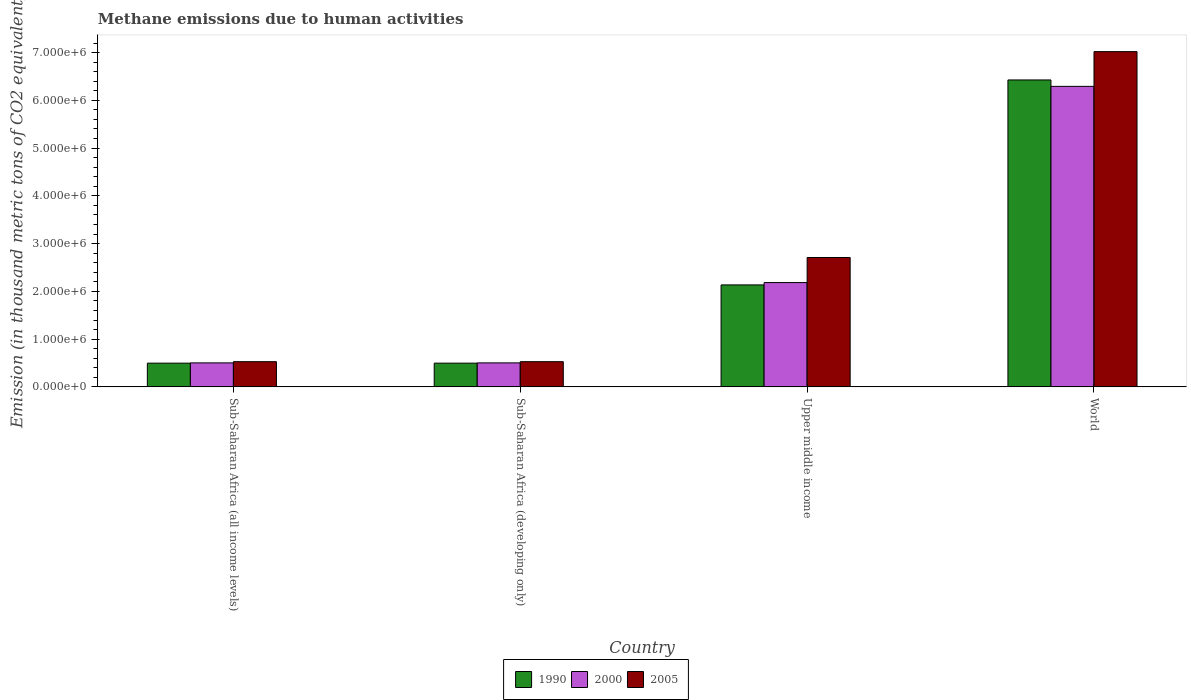How many different coloured bars are there?
Ensure brevity in your answer.  3. How many groups of bars are there?
Your answer should be compact. 4. How many bars are there on the 3rd tick from the left?
Offer a very short reply. 3. What is the label of the 3rd group of bars from the left?
Your answer should be very brief. Upper middle income. In how many cases, is the number of bars for a given country not equal to the number of legend labels?
Ensure brevity in your answer.  0. What is the amount of methane emitted in 2000 in World?
Ensure brevity in your answer.  6.29e+06. Across all countries, what is the maximum amount of methane emitted in 2005?
Your answer should be compact. 7.02e+06. Across all countries, what is the minimum amount of methane emitted in 2000?
Your response must be concise. 5.02e+05. In which country was the amount of methane emitted in 2005 minimum?
Keep it short and to the point. Sub-Saharan Africa (all income levels). What is the total amount of methane emitted in 2000 in the graph?
Your answer should be very brief. 9.48e+06. What is the difference between the amount of methane emitted in 2005 in Sub-Saharan Africa (developing only) and that in Upper middle income?
Make the answer very short. -2.18e+06. What is the difference between the amount of methane emitted in 2000 in Sub-Saharan Africa (all income levels) and the amount of methane emitted in 1990 in Upper middle income?
Offer a terse response. -1.63e+06. What is the average amount of methane emitted in 1990 per country?
Make the answer very short. 2.39e+06. What is the difference between the amount of methane emitted of/in 1990 and amount of methane emitted of/in 2000 in Sub-Saharan Africa (developing only)?
Your answer should be compact. -5608.2. What is the ratio of the amount of methane emitted in 2005 in Sub-Saharan Africa (developing only) to that in World?
Make the answer very short. 0.08. What is the difference between the highest and the second highest amount of methane emitted in 2005?
Your answer should be very brief. -4.31e+06. What is the difference between the highest and the lowest amount of methane emitted in 2005?
Ensure brevity in your answer.  6.49e+06. What does the 2nd bar from the right in Sub-Saharan Africa (developing only) represents?
Offer a terse response. 2000. Is it the case that in every country, the sum of the amount of methane emitted in 2000 and amount of methane emitted in 1990 is greater than the amount of methane emitted in 2005?
Your answer should be very brief. Yes. How many bars are there?
Your response must be concise. 12. How many countries are there in the graph?
Ensure brevity in your answer.  4. What is the difference between two consecutive major ticks on the Y-axis?
Give a very brief answer. 1.00e+06. Does the graph contain any zero values?
Ensure brevity in your answer.  No. Does the graph contain grids?
Give a very brief answer. No. Where does the legend appear in the graph?
Keep it short and to the point. Bottom center. How many legend labels are there?
Make the answer very short. 3. What is the title of the graph?
Give a very brief answer. Methane emissions due to human activities. What is the label or title of the X-axis?
Your answer should be very brief. Country. What is the label or title of the Y-axis?
Ensure brevity in your answer.  Emission (in thousand metric tons of CO2 equivalent). What is the Emission (in thousand metric tons of CO2 equivalent) in 1990 in Sub-Saharan Africa (all income levels)?
Your response must be concise. 4.97e+05. What is the Emission (in thousand metric tons of CO2 equivalent) of 2000 in Sub-Saharan Africa (all income levels)?
Provide a short and direct response. 5.02e+05. What is the Emission (in thousand metric tons of CO2 equivalent) in 2005 in Sub-Saharan Africa (all income levels)?
Your response must be concise. 5.27e+05. What is the Emission (in thousand metric tons of CO2 equivalent) in 1990 in Sub-Saharan Africa (developing only)?
Ensure brevity in your answer.  4.97e+05. What is the Emission (in thousand metric tons of CO2 equivalent) of 2000 in Sub-Saharan Africa (developing only)?
Ensure brevity in your answer.  5.02e+05. What is the Emission (in thousand metric tons of CO2 equivalent) in 2005 in Sub-Saharan Africa (developing only)?
Make the answer very short. 5.27e+05. What is the Emission (in thousand metric tons of CO2 equivalent) in 1990 in Upper middle income?
Give a very brief answer. 2.13e+06. What is the Emission (in thousand metric tons of CO2 equivalent) in 2000 in Upper middle income?
Keep it short and to the point. 2.18e+06. What is the Emission (in thousand metric tons of CO2 equivalent) of 2005 in Upper middle income?
Offer a terse response. 2.71e+06. What is the Emission (in thousand metric tons of CO2 equivalent) in 1990 in World?
Your answer should be very brief. 6.43e+06. What is the Emission (in thousand metric tons of CO2 equivalent) of 2000 in World?
Offer a very short reply. 6.29e+06. What is the Emission (in thousand metric tons of CO2 equivalent) of 2005 in World?
Provide a short and direct response. 7.02e+06. Across all countries, what is the maximum Emission (in thousand metric tons of CO2 equivalent) of 1990?
Provide a short and direct response. 6.43e+06. Across all countries, what is the maximum Emission (in thousand metric tons of CO2 equivalent) of 2000?
Offer a very short reply. 6.29e+06. Across all countries, what is the maximum Emission (in thousand metric tons of CO2 equivalent) of 2005?
Your answer should be compact. 7.02e+06. Across all countries, what is the minimum Emission (in thousand metric tons of CO2 equivalent) of 1990?
Your answer should be very brief. 4.97e+05. Across all countries, what is the minimum Emission (in thousand metric tons of CO2 equivalent) of 2000?
Provide a succinct answer. 5.02e+05. Across all countries, what is the minimum Emission (in thousand metric tons of CO2 equivalent) in 2005?
Offer a terse response. 5.27e+05. What is the total Emission (in thousand metric tons of CO2 equivalent) in 1990 in the graph?
Your response must be concise. 9.55e+06. What is the total Emission (in thousand metric tons of CO2 equivalent) of 2000 in the graph?
Offer a terse response. 9.48e+06. What is the total Emission (in thousand metric tons of CO2 equivalent) of 2005 in the graph?
Provide a succinct answer. 1.08e+07. What is the difference between the Emission (in thousand metric tons of CO2 equivalent) of 2005 in Sub-Saharan Africa (all income levels) and that in Sub-Saharan Africa (developing only)?
Ensure brevity in your answer.  0. What is the difference between the Emission (in thousand metric tons of CO2 equivalent) of 1990 in Sub-Saharan Africa (all income levels) and that in Upper middle income?
Provide a short and direct response. -1.64e+06. What is the difference between the Emission (in thousand metric tons of CO2 equivalent) in 2000 in Sub-Saharan Africa (all income levels) and that in Upper middle income?
Provide a short and direct response. -1.68e+06. What is the difference between the Emission (in thousand metric tons of CO2 equivalent) in 2005 in Sub-Saharan Africa (all income levels) and that in Upper middle income?
Provide a short and direct response. -2.18e+06. What is the difference between the Emission (in thousand metric tons of CO2 equivalent) of 1990 in Sub-Saharan Africa (all income levels) and that in World?
Offer a terse response. -5.93e+06. What is the difference between the Emission (in thousand metric tons of CO2 equivalent) of 2000 in Sub-Saharan Africa (all income levels) and that in World?
Give a very brief answer. -5.79e+06. What is the difference between the Emission (in thousand metric tons of CO2 equivalent) in 2005 in Sub-Saharan Africa (all income levels) and that in World?
Your answer should be compact. -6.49e+06. What is the difference between the Emission (in thousand metric tons of CO2 equivalent) in 1990 in Sub-Saharan Africa (developing only) and that in Upper middle income?
Provide a succinct answer. -1.64e+06. What is the difference between the Emission (in thousand metric tons of CO2 equivalent) of 2000 in Sub-Saharan Africa (developing only) and that in Upper middle income?
Offer a terse response. -1.68e+06. What is the difference between the Emission (in thousand metric tons of CO2 equivalent) of 2005 in Sub-Saharan Africa (developing only) and that in Upper middle income?
Make the answer very short. -2.18e+06. What is the difference between the Emission (in thousand metric tons of CO2 equivalent) in 1990 in Sub-Saharan Africa (developing only) and that in World?
Provide a succinct answer. -5.93e+06. What is the difference between the Emission (in thousand metric tons of CO2 equivalent) in 2000 in Sub-Saharan Africa (developing only) and that in World?
Offer a very short reply. -5.79e+06. What is the difference between the Emission (in thousand metric tons of CO2 equivalent) in 2005 in Sub-Saharan Africa (developing only) and that in World?
Your answer should be very brief. -6.49e+06. What is the difference between the Emission (in thousand metric tons of CO2 equivalent) in 1990 in Upper middle income and that in World?
Give a very brief answer. -4.29e+06. What is the difference between the Emission (in thousand metric tons of CO2 equivalent) in 2000 in Upper middle income and that in World?
Offer a very short reply. -4.11e+06. What is the difference between the Emission (in thousand metric tons of CO2 equivalent) of 2005 in Upper middle income and that in World?
Ensure brevity in your answer.  -4.31e+06. What is the difference between the Emission (in thousand metric tons of CO2 equivalent) of 1990 in Sub-Saharan Africa (all income levels) and the Emission (in thousand metric tons of CO2 equivalent) of 2000 in Sub-Saharan Africa (developing only)?
Offer a terse response. -5608.2. What is the difference between the Emission (in thousand metric tons of CO2 equivalent) in 1990 in Sub-Saharan Africa (all income levels) and the Emission (in thousand metric tons of CO2 equivalent) in 2005 in Sub-Saharan Africa (developing only)?
Offer a very short reply. -3.07e+04. What is the difference between the Emission (in thousand metric tons of CO2 equivalent) in 2000 in Sub-Saharan Africa (all income levels) and the Emission (in thousand metric tons of CO2 equivalent) in 2005 in Sub-Saharan Africa (developing only)?
Your answer should be very brief. -2.51e+04. What is the difference between the Emission (in thousand metric tons of CO2 equivalent) of 1990 in Sub-Saharan Africa (all income levels) and the Emission (in thousand metric tons of CO2 equivalent) of 2000 in Upper middle income?
Keep it short and to the point. -1.69e+06. What is the difference between the Emission (in thousand metric tons of CO2 equivalent) in 1990 in Sub-Saharan Africa (all income levels) and the Emission (in thousand metric tons of CO2 equivalent) in 2005 in Upper middle income?
Your answer should be very brief. -2.21e+06. What is the difference between the Emission (in thousand metric tons of CO2 equivalent) of 2000 in Sub-Saharan Africa (all income levels) and the Emission (in thousand metric tons of CO2 equivalent) of 2005 in Upper middle income?
Offer a terse response. -2.21e+06. What is the difference between the Emission (in thousand metric tons of CO2 equivalent) in 1990 in Sub-Saharan Africa (all income levels) and the Emission (in thousand metric tons of CO2 equivalent) in 2000 in World?
Your response must be concise. -5.80e+06. What is the difference between the Emission (in thousand metric tons of CO2 equivalent) in 1990 in Sub-Saharan Africa (all income levels) and the Emission (in thousand metric tons of CO2 equivalent) in 2005 in World?
Ensure brevity in your answer.  -6.52e+06. What is the difference between the Emission (in thousand metric tons of CO2 equivalent) in 2000 in Sub-Saharan Africa (all income levels) and the Emission (in thousand metric tons of CO2 equivalent) in 2005 in World?
Make the answer very short. -6.52e+06. What is the difference between the Emission (in thousand metric tons of CO2 equivalent) of 1990 in Sub-Saharan Africa (developing only) and the Emission (in thousand metric tons of CO2 equivalent) of 2000 in Upper middle income?
Provide a succinct answer. -1.69e+06. What is the difference between the Emission (in thousand metric tons of CO2 equivalent) of 1990 in Sub-Saharan Africa (developing only) and the Emission (in thousand metric tons of CO2 equivalent) of 2005 in Upper middle income?
Ensure brevity in your answer.  -2.21e+06. What is the difference between the Emission (in thousand metric tons of CO2 equivalent) of 2000 in Sub-Saharan Africa (developing only) and the Emission (in thousand metric tons of CO2 equivalent) of 2005 in Upper middle income?
Provide a succinct answer. -2.21e+06. What is the difference between the Emission (in thousand metric tons of CO2 equivalent) of 1990 in Sub-Saharan Africa (developing only) and the Emission (in thousand metric tons of CO2 equivalent) of 2000 in World?
Provide a succinct answer. -5.80e+06. What is the difference between the Emission (in thousand metric tons of CO2 equivalent) of 1990 in Sub-Saharan Africa (developing only) and the Emission (in thousand metric tons of CO2 equivalent) of 2005 in World?
Your answer should be very brief. -6.52e+06. What is the difference between the Emission (in thousand metric tons of CO2 equivalent) of 2000 in Sub-Saharan Africa (developing only) and the Emission (in thousand metric tons of CO2 equivalent) of 2005 in World?
Your answer should be compact. -6.52e+06. What is the difference between the Emission (in thousand metric tons of CO2 equivalent) of 1990 in Upper middle income and the Emission (in thousand metric tons of CO2 equivalent) of 2000 in World?
Provide a succinct answer. -4.16e+06. What is the difference between the Emission (in thousand metric tons of CO2 equivalent) of 1990 in Upper middle income and the Emission (in thousand metric tons of CO2 equivalent) of 2005 in World?
Offer a terse response. -4.88e+06. What is the difference between the Emission (in thousand metric tons of CO2 equivalent) of 2000 in Upper middle income and the Emission (in thousand metric tons of CO2 equivalent) of 2005 in World?
Give a very brief answer. -4.84e+06. What is the average Emission (in thousand metric tons of CO2 equivalent) of 1990 per country?
Offer a very short reply. 2.39e+06. What is the average Emission (in thousand metric tons of CO2 equivalent) in 2000 per country?
Offer a very short reply. 2.37e+06. What is the average Emission (in thousand metric tons of CO2 equivalent) in 2005 per country?
Keep it short and to the point. 2.70e+06. What is the difference between the Emission (in thousand metric tons of CO2 equivalent) in 1990 and Emission (in thousand metric tons of CO2 equivalent) in 2000 in Sub-Saharan Africa (all income levels)?
Your answer should be compact. -5608.2. What is the difference between the Emission (in thousand metric tons of CO2 equivalent) of 1990 and Emission (in thousand metric tons of CO2 equivalent) of 2005 in Sub-Saharan Africa (all income levels)?
Keep it short and to the point. -3.07e+04. What is the difference between the Emission (in thousand metric tons of CO2 equivalent) in 2000 and Emission (in thousand metric tons of CO2 equivalent) in 2005 in Sub-Saharan Africa (all income levels)?
Offer a very short reply. -2.51e+04. What is the difference between the Emission (in thousand metric tons of CO2 equivalent) in 1990 and Emission (in thousand metric tons of CO2 equivalent) in 2000 in Sub-Saharan Africa (developing only)?
Give a very brief answer. -5608.2. What is the difference between the Emission (in thousand metric tons of CO2 equivalent) in 1990 and Emission (in thousand metric tons of CO2 equivalent) in 2005 in Sub-Saharan Africa (developing only)?
Provide a short and direct response. -3.07e+04. What is the difference between the Emission (in thousand metric tons of CO2 equivalent) of 2000 and Emission (in thousand metric tons of CO2 equivalent) of 2005 in Sub-Saharan Africa (developing only)?
Provide a succinct answer. -2.51e+04. What is the difference between the Emission (in thousand metric tons of CO2 equivalent) of 1990 and Emission (in thousand metric tons of CO2 equivalent) of 2000 in Upper middle income?
Offer a terse response. -4.89e+04. What is the difference between the Emission (in thousand metric tons of CO2 equivalent) of 1990 and Emission (in thousand metric tons of CO2 equivalent) of 2005 in Upper middle income?
Keep it short and to the point. -5.74e+05. What is the difference between the Emission (in thousand metric tons of CO2 equivalent) of 2000 and Emission (in thousand metric tons of CO2 equivalent) of 2005 in Upper middle income?
Give a very brief answer. -5.25e+05. What is the difference between the Emission (in thousand metric tons of CO2 equivalent) in 1990 and Emission (in thousand metric tons of CO2 equivalent) in 2000 in World?
Provide a short and direct response. 1.34e+05. What is the difference between the Emission (in thousand metric tons of CO2 equivalent) of 1990 and Emission (in thousand metric tons of CO2 equivalent) of 2005 in World?
Give a very brief answer. -5.93e+05. What is the difference between the Emission (in thousand metric tons of CO2 equivalent) of 2000 and Emission (in thousand metric tons of CO2 equivalent) of 2005 in World?
Make the answer very short. -7.27e+05. What is the ratio of the Emission (in thousand metric tons of CO2 equivalent) in 2000 in Sub-Saharan Africa (all income levels) to that in Sub-Saharan Africa (developing only)?
Your response must be concise. 1. What is the ratio of the Emission (in thousand metric tons of CO2 equivalent) in 2005 in Sub-Saharan Africa (all income levels) to that in Sub-Saharan Africa (developing only)?
Give a very brief answer. 1. What is the ratio of the Emission (in thousand metric tons of CO2 equivalent) in 1990 in Sub-Saharan Africa (all income levels) to that in Upper middle income?
Provide a short and direct response. 0.23. What is the ratio of the Emission (in thousand metric tons of CO2 equivalent) in 2000 in Sub-Saharan Africa (all income levels) to that in Upper middle income?
Offer a very short reply. 0.23. What is the ratio of the Emission (in thousand metric tons of CO2 equivalent) in 2005 in Sub-Saharan Africa (all income levels) to that in Upper middle income?
Give a very brief answer. 0.19. What is the ratio of the Emission (in thousand metric tons of CO2 equivalent) of 1990 in Sub-Saharan Africa (all income levels) to that in World?
Your response must be concise. 0.08. What is the ratio of the Emission (in thousand metric tons of CO2 equivalent) of 2000 in Sub-Saharan Africa (all income levels) to that in World?
Make the answer very short. 0.08. What is the ratio of the Emission (in thousand metric tons of CO2 equivalent) in 2005 in Sub-Saharan Africa (all income levels) to that in World?
Offer a terse response. 0.08. What is the ratio of the Emission (in thousand metric tons of CO2 equivalent) in 1990 in Sub-Saharan Africa (developing only) to that in Upper middle income?
Offer a terse response. 0.23. What is the ratio of the Emission (in thousand metric tons of CO2 equivalent) in 2000 in Sub-Saharan Africa (developing only) to that in Upper middle income?
Make the answer very short. 0.23. What is the ratio of the Emission (in thousand metric tons of CO2 equivalent) in 2005 in Sub-Saharan Africa (developing only) to that in Upper middle income?
Your response must be concise. 0.19. What is the ratio of the Emission (in thousand metric tons of CO2 equivalent) in 1990 in Sub-Saharan Africa (developing only) to that in World?
Provide a short and direct response. 0.08. What is the ratio of the Emission (in thousand metric tons of CO2 equivalent) in 2000 in Sub-Saharan Africa (developing only) to that in World?
Your response must be concise. 0.08. What is the ratio of the Emission (in thousand metric tons of CO2 equivalent) of 2005 in Sub-Saharan Africa (developing only) to that in World?
Offer a very short reply. 0.08. What is the ratio of the Emission (in thousand metric tons of CO2 equivalent) of 1990 in Upper middle income to that in World?
Offer a very short reply. 0.33. What is the ratio of the Emission (in thousand metric tons of CO2 equivalent) in 2000 in Upper middle income to that in World?
Provide a succinct answer. 0.35. What is the ratio of the Emission (in thousand metric tons of CO2 equivalent) of 2005 in Upper middle income to that in World?
Offer a very short reply. 0.39. What is the difference between the highest and the second highest Emission (in thousand metric tons of CO2 equivalent) in 1990?
Keep it short and to the point. 4.29e+06. What is the difference between the highest and the second highest Emission (in thousand metric tons of CO2 equivalent) in 2000?
Ensure brevity in your answer.  4.11e+06. What is the difference between the highest and the second highest Emission (in thousand metric tons of CO2 equivalent) in 2005?
Your response must be concise. 4.31e+06. What is the difference between the highest and the lowest Emission (in thousand metric tons of CO2 equivalent) of 1990?
Keep it short and to the point. 5.93e+06. What is the difference between the highest and the lowest Emission (in thousand metric tons of CO2 equivalent) of 2000?
Your answer should be very brief. 5.79e+06. What is the difference between the highest and the lowest Emission (in thousand metric tons of CO2 equivalent) of 2005?
Keep it short and to the point. 6.49e+06. 